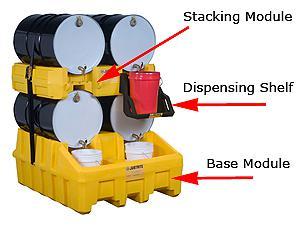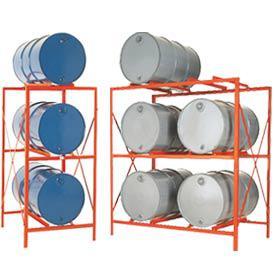The first image is the image on the left, the second image is the image on the right. Analyze the images presented: Is the assertion "Each image contains at least one blue barrel, and at least 6 blue barrels in total are shown." valid? Answer yes or no. No. The first image is the image on the left, the second image is the image on the right. Considering the images on both sides, is "One image shows exactly two blue barrels." valid? Answer yes or no. No. 